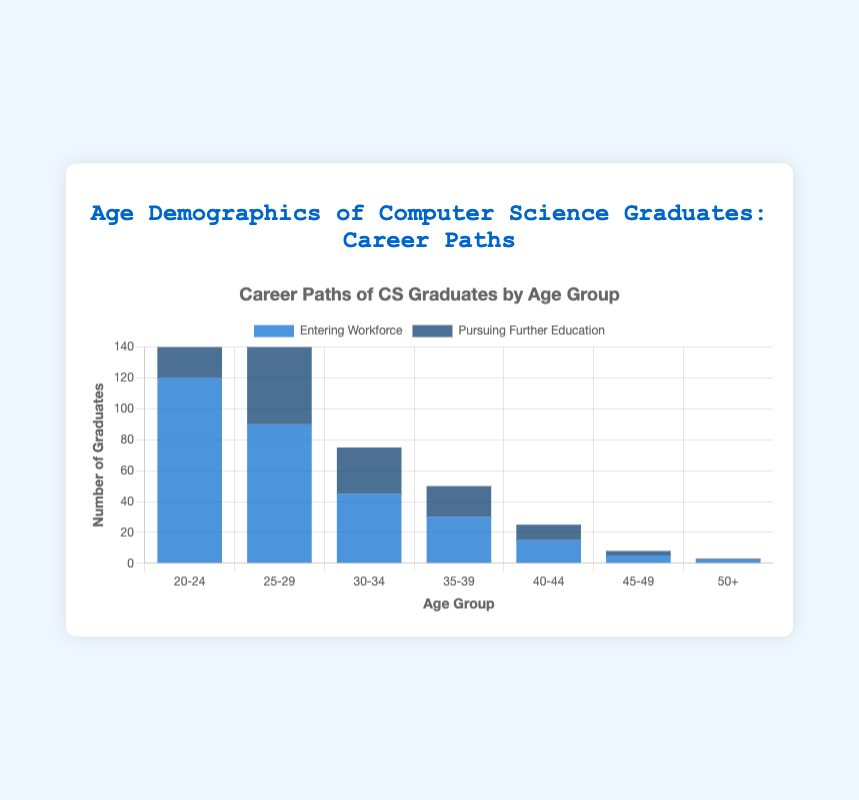What is the total number of graduates aged 20-24? The number of graduates aged 20-24 entering the workforce is 120, and those pursuing further education is 80. Adding these together gives 120 + 80 = 200.
Answer: 200 Which age group has the highest number of graduates entering the workforce? By comparing the values for "Entering Workforce" across all age groups, the 20-24 age group has the highest value at 120.
Answer: 20-24 How many more graduates aged 25-29 are entering the workforce compared to pursuing further education? The number of graduates aged 25-29 entering the workforce is 90, while those pursuing further education is 60. The difference is 90 - 60 = 30.
Answer: 30 What is the ratio of graduates aged 30-34 entering the workforce to those pursuing further education? The number of graduates aged 30-34 entering the workforce is 45, and those pursuing further education is 30. The ratio is 45:30, which simplifies to 3:2.
Answer: 3:2 Which age group has the least number of graduates pursuing further education? By comparing the values for "Pursuing Further Education" across all age groups, the 50+ age group has the least value at 1.
Answer: 50+ What is the sum of graduates aged 35-39 in both categories? The number of graduates aged 35-39 entering the workforce is 30, and those pursuing further education is 20. Adding these together gives 30 + 20 = 50.
Answer: 50 What is the difference between the number of graduates entering the workforce and those pursuing further education for the 40-44 age group? The number of graduates aged 40-44 entering the workforce is 15, and those pursuing further education is 10. The difference is 15 - 10 = 5.
Answer: 5 Which is greater, the number of graduates aged 45-49 entering the workforce or the number aged 50+ pursuing further education? The number of graduates aged 45-49 entering the workforce is 5, and those aged 50+ pursuing further education is 1. Therefore, 5 is greater than 1.
Answer: Graduates aged 45-49 entering the workforce What is the average number of graduates pursuing further education across all age groups? Sum the numbers of graduates pursuing further education across all age groups, which is 80 + 60 + 30 + 20 + 10 + 3 + 1 = 204. There are 7 age groups, so the average is 204 / 7 ≈ 29.14.
Answer: 29.14 How does the height of the bar for 25-29 entering the workforce compare to the height for 20-24 entering the workforce? The bar for the 25-29 age group entering the workforce (height 90) is shorter than the bar for the 20-24 age group entering the workforce (height 120).
Answer: Shorter 